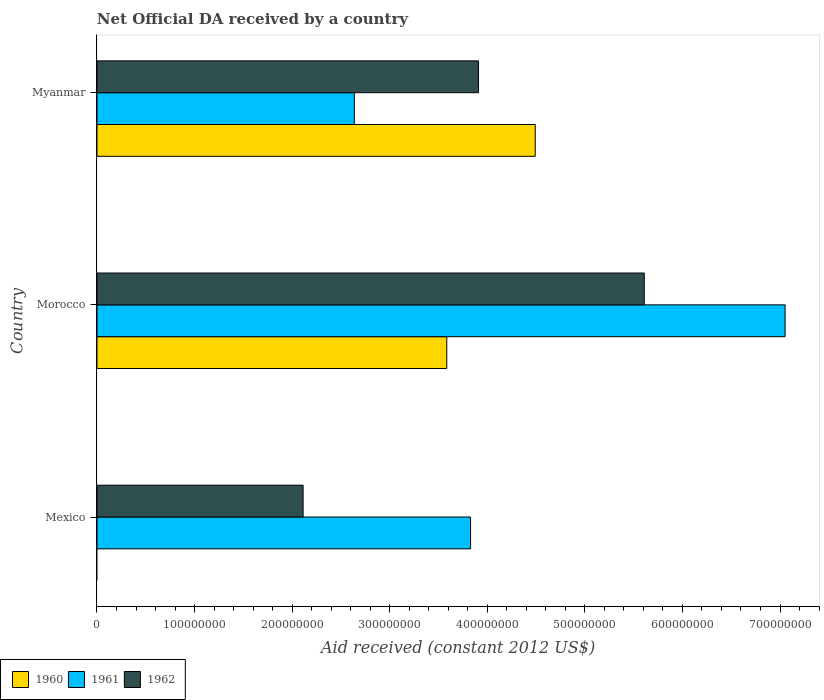How many different coloured bars are there?
Your answer should be compact. 3. How many groups of bars are there?
Make the answer very short. 3. Are the number of bars per tick equal to the number of legend labels?
Provide a short and direct response. No. Are the number of bars on each tick of the Y-axis equal?
Offer a terse response. No. What is the label of the 3rd group of bars from the top?
Offer a very short reply. Mexico. What is the net official development assistance aid received in 1962 in Mexico?
Offer a terse response. 2.11e+08. Across all countries, what is the maximum net official development assistance aid received in 1960?
Your answer should be compact. 4.49e+08. Across all countries, what is the minimum net official development assistance aid received in 1962?
Make the answer very short. 2.11e+08. In which country was the net official development assistance aid received in 1960 maximum?
Keep it short and to the point. Myanmar. What is the total net official development assistance aid received in 1962 in the graph?
Ensure brevity in your answer.  1.16e+09. What is the difference between the net official development assistance aid received in 1961 in Mexico and that in Myanmar?
Ensure brevity in your answer.  1.19e+08. What is the difference between the net official development assistance aid received in 1960 in Myanmar and the net official development assistance aid received in 1961 in Morocco?
Make the answer very short. -2.56e+08. What is the average net official development assistance aid received in 1961 per country?
Offer a very short reply. 4.51e+08. What is the difference between the net official development assistance aid received in 1962 and net official development assistance aid received in 1960 in Morocco?
Your answer should be compact. 2.02e+08. In how many countries, is the net official development assistance aid received in 1961 greater than 80000000 US$?
Keep it short and to the point. 3. What is the ratio of the net official development assistance aid received in 1961 in Mexico to that in Morocco?
Offer a terse response. 0.54. Is the net official development assistance aid received in 1961 in Mexico less than that in Morocco?
Offer a very short reply. Yes. What is the difference between the highest and the second highest net official development assistance aid received in 1961?
Ensure brevity in your answer.  3.22e+08. What is the difference between the highest and the lowest net official development assistance aid received in 1961?
Your response must be concise. 4.41e+08. Is the sum of the net official development assistance aid received in 1962 in Mexico and Morocco greater than the maximum net official development assistance aid received in 1960 across all countries?
Offer a terse response. Yes. Is it the case that in every country, the sum of the net official development assistance aid received in 1960 and net official development assistance aid received in 1961 is greater than the net official development assistance aid received in 1962?
Your response must be concise. Yes. How many bars are there?
Your answer should be very brief. 8. Are all the bars in the graph horizontal?
Keep it short and to the point. Yes. How many countries are there in the graph?
Ensure brevity in your answer.  3. What is the difference between two consecutive major ticks on the X-axis?
Provide a short and direct response. 1.00e+08. Where does the legend appear in the graph?
Offer a terse response. Bottom left. How many legend labels are there?
Ensure brevity in your answer.  3. What is the title of the graph?
Keep it short and to the point. Net Official DA received by a country. Does "1980" appear as one of the legend labels in the graph?
Your answer should be very brief. No. What is the label or title of the X-axis?
Your response must be concise. Aid received (constant 2012 US$). What is the label or title of the Y-axis?
Give a very brief answer. Country. What is the Aid received (constant 2012 US$) in 1961 in Mexico?
Give a very brief answer. 3.83e+08. What is the Aid received (constant 2012 US$) in 1962 in Mexico?
Offer a terse response. 2.11e+08. What is the Aid received (constant 2012 US$) of 1960 in Morocco?
Offer a very short reply. 3.58e+08. What is the Aid received (constant 2012 US$) of 1961 in Morocco?
Provide a short and direct response. 7.05e+08. What is the Aid received (constant 2012 US$) of 1962 in Morocco?
Give a very brief answer. 5.61e+08. What is the Aid received (constant 2012 US$) in 1960 in Myanmar?
Offer a terse response. 4.49e+08. What is the Aid received (constant 2012 US$) in 1961 in Myanmar?
Provide a short and direct response. 2.64e+08. What is the Aid received (constant 2012 US$) in 1962 in Myanmar?
Your response must be concise. 3.91e+08. Across all countries, what is the maximum Aid received (constant 2012 US$) in 1960?
Offer a very short reply. 4.49e+08. Across all countries, what is the maximum Aid received (constant 2012 US$) in 1961?
Make the answer very short. 7.05e+08. Across all countries, what is the maximum Aid received (constant 2012 US$) of 1962?
Provide a short and direct response. 5.61e+08. Across all countries, what is the minimum Aid received (constant 2012 US$) of 1961?
Offer a very short reply. 2.64e+08. Across all countries, what is the minimum Aid received (constant 2012 US$) of 1962?
Give a very brief answer. 2.11e+08. What is the total Aid received (constant 2012 US$) in 1960 in the graph?
Your answer should be very brief. 8.08e+08. What is the total Aid received (constant 2012 US$) in 1961 in the graph?
Ensure brevity in your answer.  1.35e+09. What is the total Aid received (constant 2012 US$) of 1962 in the graph?
Provide a short and direct response. 1.16e+09. What is the difference between the Aid received (constant 2012 US$) of 1961 in Mexico and that in Morocco?
Make the answer very short. -3.22e+08. What is the difference between the Aid received (constant 2012 US$) in 1962 in Mexico and that in Morocco?
Keep it short and to the point. -3.50e+08. What is the difference between the Aid received (constant 2012 US$) of 1961 in Mexico and that in Myanmar?
Keep it short and to the point. 1.19e+08. What is the difference between the Aid received (constant 2012 US$) in 1962 in Mexico and that in Myanmar?
Provide a succinct answer. -1.80e+08. What is the difference between the Aid received (constant 2012 US$) of 1960 in Morocco and that in Myanmar?
Provide a succinct answer. -9.06e+07. What is the difference between the Aid received (constant 2012 US$) of 1961 in Morocco and that in Myanmar?
Offer a very short reply. 4.41e+08. What is the difference between the Aid received (constant 2012 US$) of 1962 in Morocco and that in Myanmar?
Make the answer very short. 1.70e+08. What is the difference between the Aid received (constant 2012 US$) in 1961 in Mexico and the Aid received (constant 2012 US$) in 1962 in Morocco?
Offer a terse response. -1.78e+08. What is the difference between the Aid received (constant 2012 US$) of 1961 in Mexico and the Aid received (constant 2012 US$) of 1962 in Myanmar?
Provide a short and direct response. -8.16e+06. What is the difference between the Aid received (constant 2012 US$) of 1960 in Morocco and the Aid received (constant 2012 US$) of 1961 in Myanmar?
Make the answer very short. 9.47e+07. What is the difference between the Aid received (constant 2012 US$) in 1960 in Morocco and the Aid received (constant 2012 US$) in 1962 in Myanmar?
Keep it short and to the point. -3.25e+07. What is the difference between the Aid received (constant 2012 US$) of 1961 in Morocco and the Aid received (constant 2012 US$) of 1962 in Myanmar?
Provide a succinct answer. 3.14e+08. What is the average Aid received (constant 2012 US$) in 1960 per country?
Your answer should be compact. 2.69e+08. What is the average Aid received (constant 2012 US$) of 1961 per country?
Make the answer very short. 4.51e+08. What is the average Aid received (constant 2012 US$) of 1962 per country?
Ensure brevity in your answer.  3.88e+08. What is the difference between the Aid received (constant 2012 US$) of 1961 and Aid received (constant 2012 US$) of 1962 in Mexico?
Ensure brevity in your answer.  1.72e+08. What is the difference between the Aid received (constant 2012 US$) in 1960 and Aid received (constant 2012 US$) in 1961 in Morocco?
Provide a short and direct response. -3.47e+08. What is the difference between the Aid received (constant 2012 US$) in 1960 and Aid received (constant 2012 US$) in 1962 in Morocco?
Ensure brevity in your answer.  -2.02e+08. What is the difference between the Aid received (constant 2012 US$) of 1961 and Aid received (constant 2012 US$) of 1962 in Morocco?
Your response must be concise. 1.44e+08. What is the difference between the Aid received (constant 2012 US$) in 1960 and Aid received (constant 2012 US$) in 1961 in Myanmar?
Your response must be concise. 1.85e+08. What is the difference between the Aid received (constant 2012 US$) in 1960 and Aid received (constant 2012 US$) in 1962 in Myanmar?
Offer a terse response. 5.81e+07. What is the difference between the Aid received (constant 2012 US$) of 1961 and Aid received (constant 2012 US$) of 1962 in Myanmar?
Your response must be concise. -1.27e+08. What is the ratio of the Aid received (constant 2012 US$) of 1961 in Mexico to that in Morocco?
Provide a succinct answer. 0.54. What is the ratio of the Aid received (constant 2012 US$) in 1962 in Mexico to that in Morocco?
Your answer should be very brief. 0.38. What is the ratio of the Aid received (constant 2012 US$) of 1961 in Mexico to that in Myanmar?
Your response must be concise. 1.45. What is the ratio of the Aid received (constant 2012 US$) in 1962 in Mexico to that in Myanmar?
Provide a short and direct response. 0.54. What is the ratio of the Aid received (constant 2012 US$) of 1960 in Morocco to that in Myanmar?
Give a very brief answer. 0.8. What is the ratio of the Aid received (constant 2012 US$) of 1961 in Morocco to that in Myanmar?
Keep it short and to the point. 2.67. What is the ratio of the Aid received (constant 2012 US$) of 1962 in Morocco to that in Myanmar?
Ensure brevity in your answer.  1.43. What is the difference between the highest and the second highest Aid received (constant 2012 US$) in 1961?
Offer a very short reply. 3.22e+08. What is the difference between the highest and the second highest Aid received (constant 2012 US$) of 1962?
Make the answer very short. 1.70e+08. What is the difference between the highest and the lowest Aid received (constant 2012 US$) of 1960?
Provide a succinct answer. 4.49e+08. What is the difference between the highest and the lowest Aid received (constant 2012 US$) in 1961?
Ensure brevity in your answer.  4.41e+08. What is the difference between the highest and the lowest Aid received (constant 2012 US$) in 1962?
Offer a terse response. 3.50e+08. 